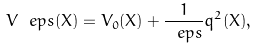<formula> <loc_0><loc_0><loc_500><loc_500>V _ { \ } e p s ( X ) = V _ { 0 } ( X ) + \frac { 1 } { \ e p s } q ^ { 2 } ( X ) ,</formula> 